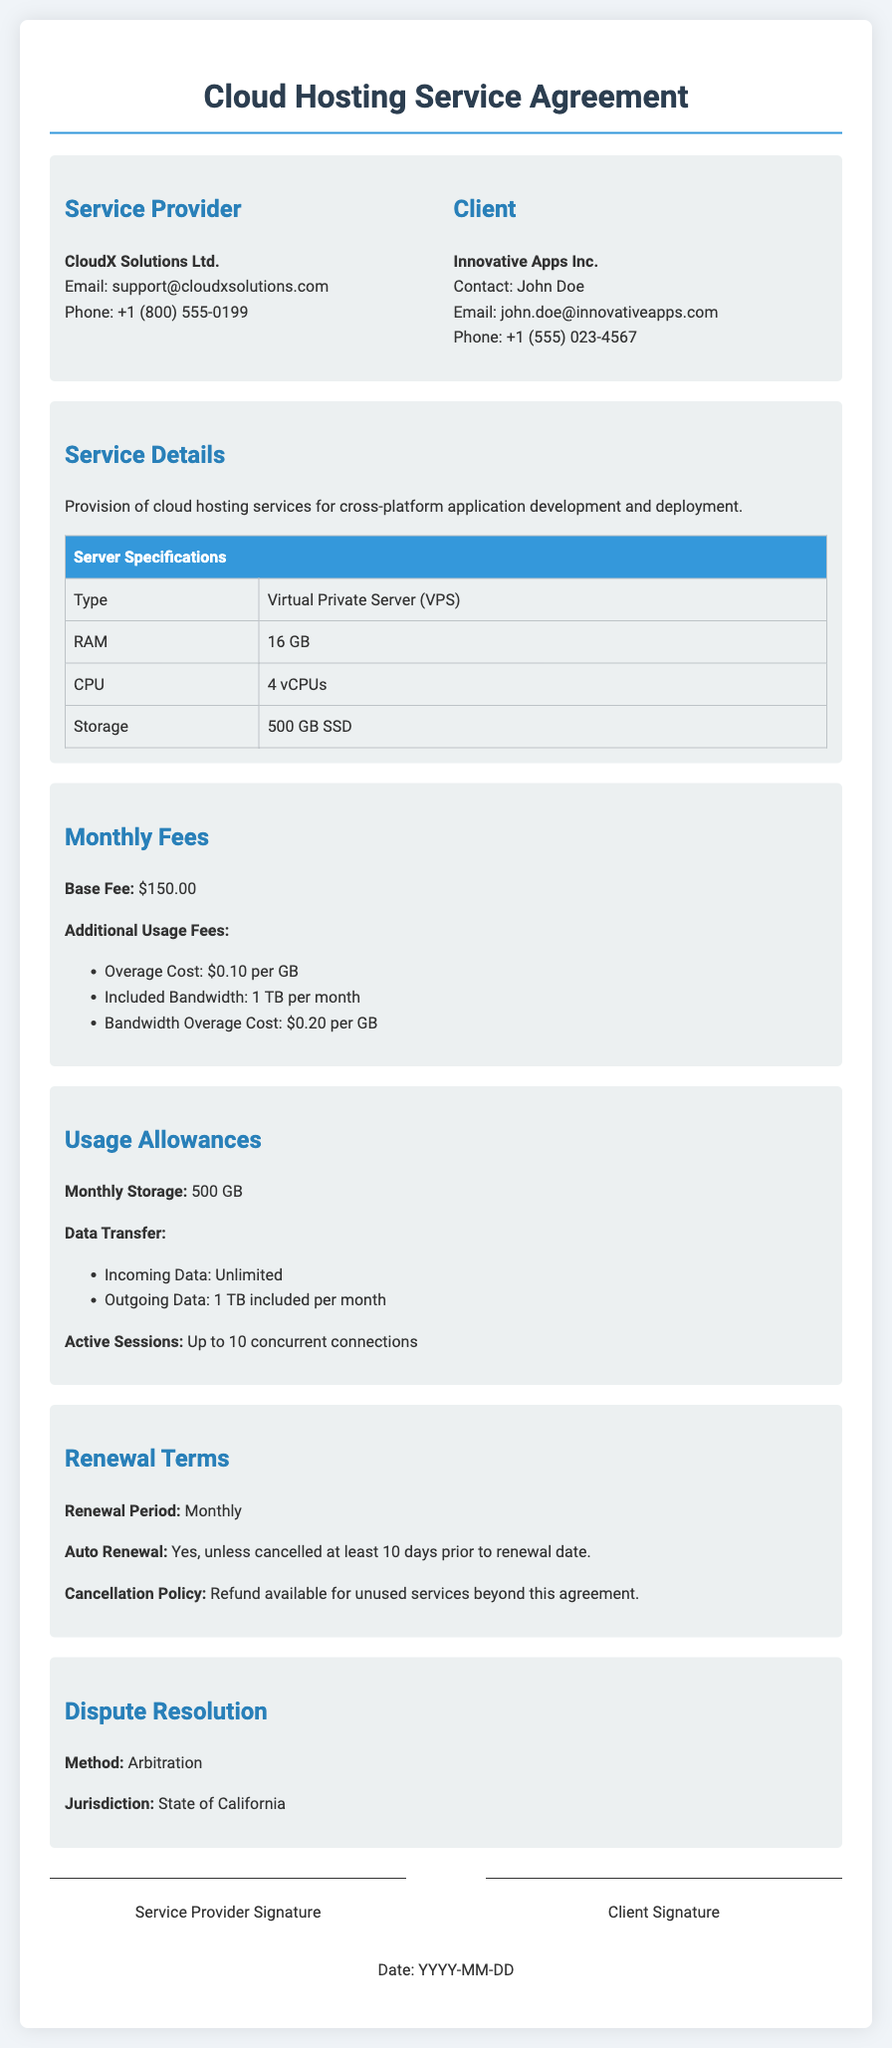What is the name of the service provider? The service provider is mentioned in the document as CloudX Solutions Ltd.
Answer: CloudX Solutions Ltd What is the base fee for the service? The document states that the base fee is $150.00.
Answer: $150.00 What is the included bandwidth per month? The document specifies that the included bandwidth is 1 TB per month.
Answer: 1 TB What is the overage cost per GB for additional usage? The document notes that the overage cost is $0.10 per GB.
Answer: $0.10 How many active sessions are allowed? The document indicates that up to 10 concurrent connections are allowed.
Answer: 10 What is the cancellation notice period for auto renewal? The document specifies that cancellation must be at least 10 days prior to the renewal date.
Answer: 10 days What is the method of dispute resolution? The document describes the method of dispute resolution as arbitration.
Answer: Arbitration What type of server is provided? The document states that a Virtual Private Server (VPS) is provided.
Answer: Virtual Private Server (VPS) What is the storage limit per month? The document states that the monthly storage limit is 500 GB.
Answer: 500 GB 